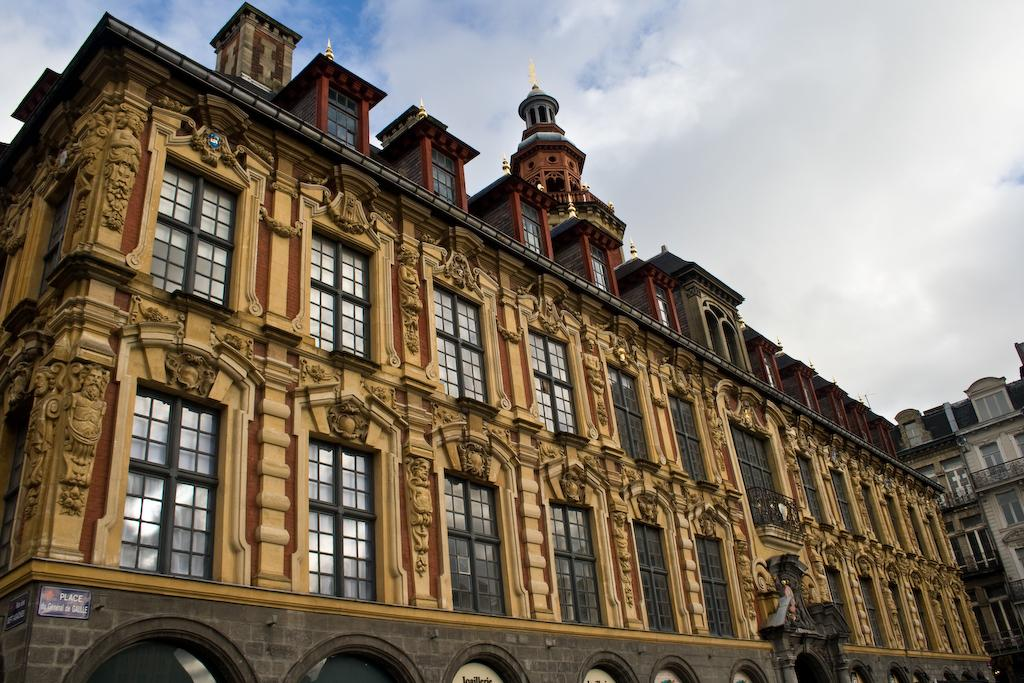What type of structures can be seen in the image? There are buildings in the image. What can be seen in the sky in the image? There are clouds visible in the sky in the image. Can you tell me how many lawyers are present in the image? There is no reference to any lawyers in the image, so it is not possible to determine how many might be present. What type of crook can be seen in the image? There is no crook present in the image; it features buildings and clouds in the sky. 